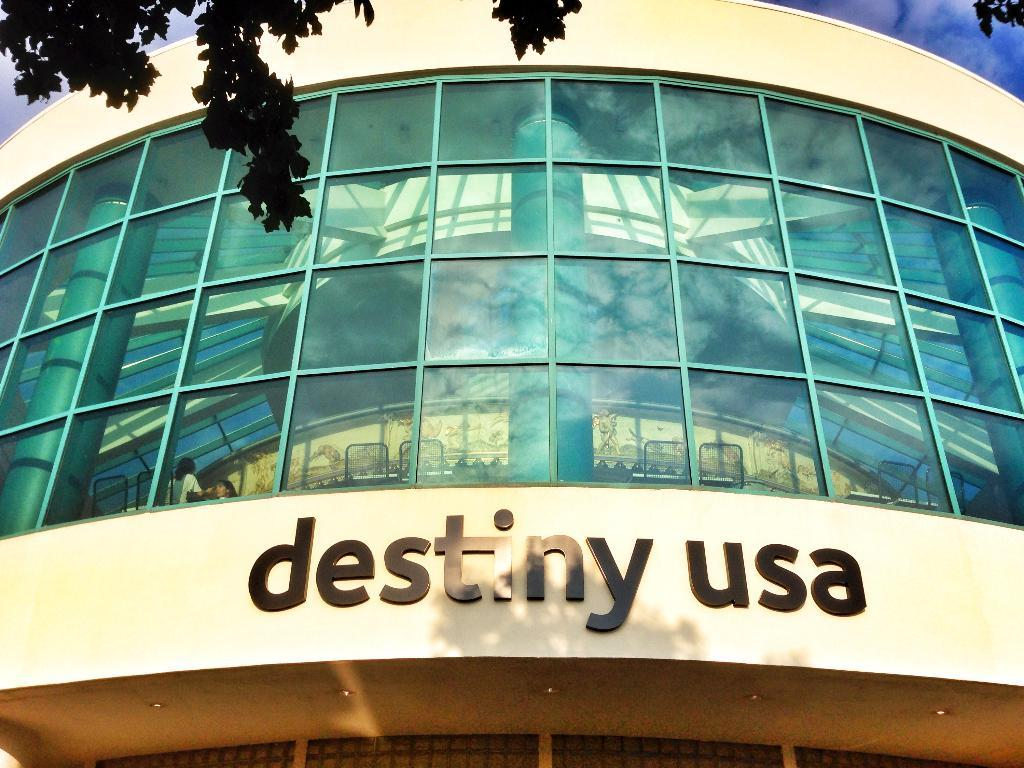What is the main subject in the center of the image? There is a building in the center of the image. What can be seen at the top of the image? Trees and the sky are visible at the top of the image. What type of pencil can be seen in the image? There is no pencil present in the image. 